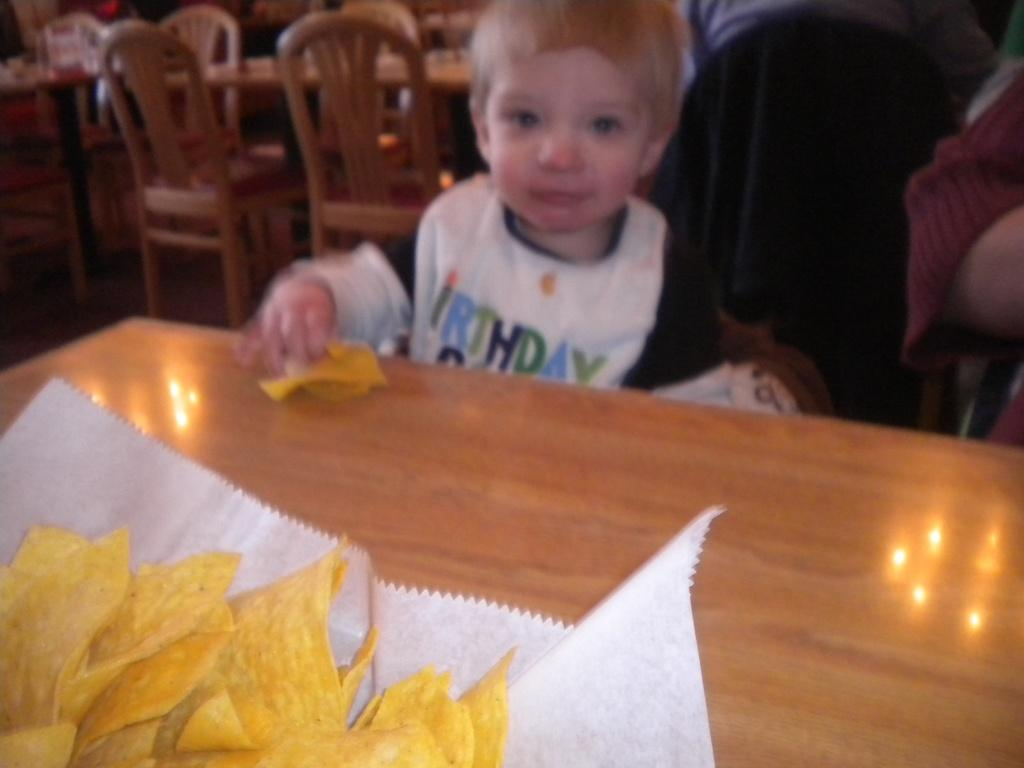Who is the main subject in the image? There is a little boy in the image. What is the little boy holding? The boy is holding chips. What else can be seen on the table in the image? There are chips on a tissue on the table. Can you describe the overall quality of the image? The image is blurred. What type of train is visible in the image? There is no train present in the image. What trade agreement is being discussed in the image? There is no discussion of trade agreements in the image. 